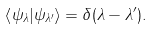<formula> <loc_0><loc_0><loc_500><loc_500>\left \langle \psi _ { \lambda } | \psi _ { \lambda ^ { \prime } } \right \rangle = \delta ( \lambda - \lambda ^ { \prime } ) .</formula> 